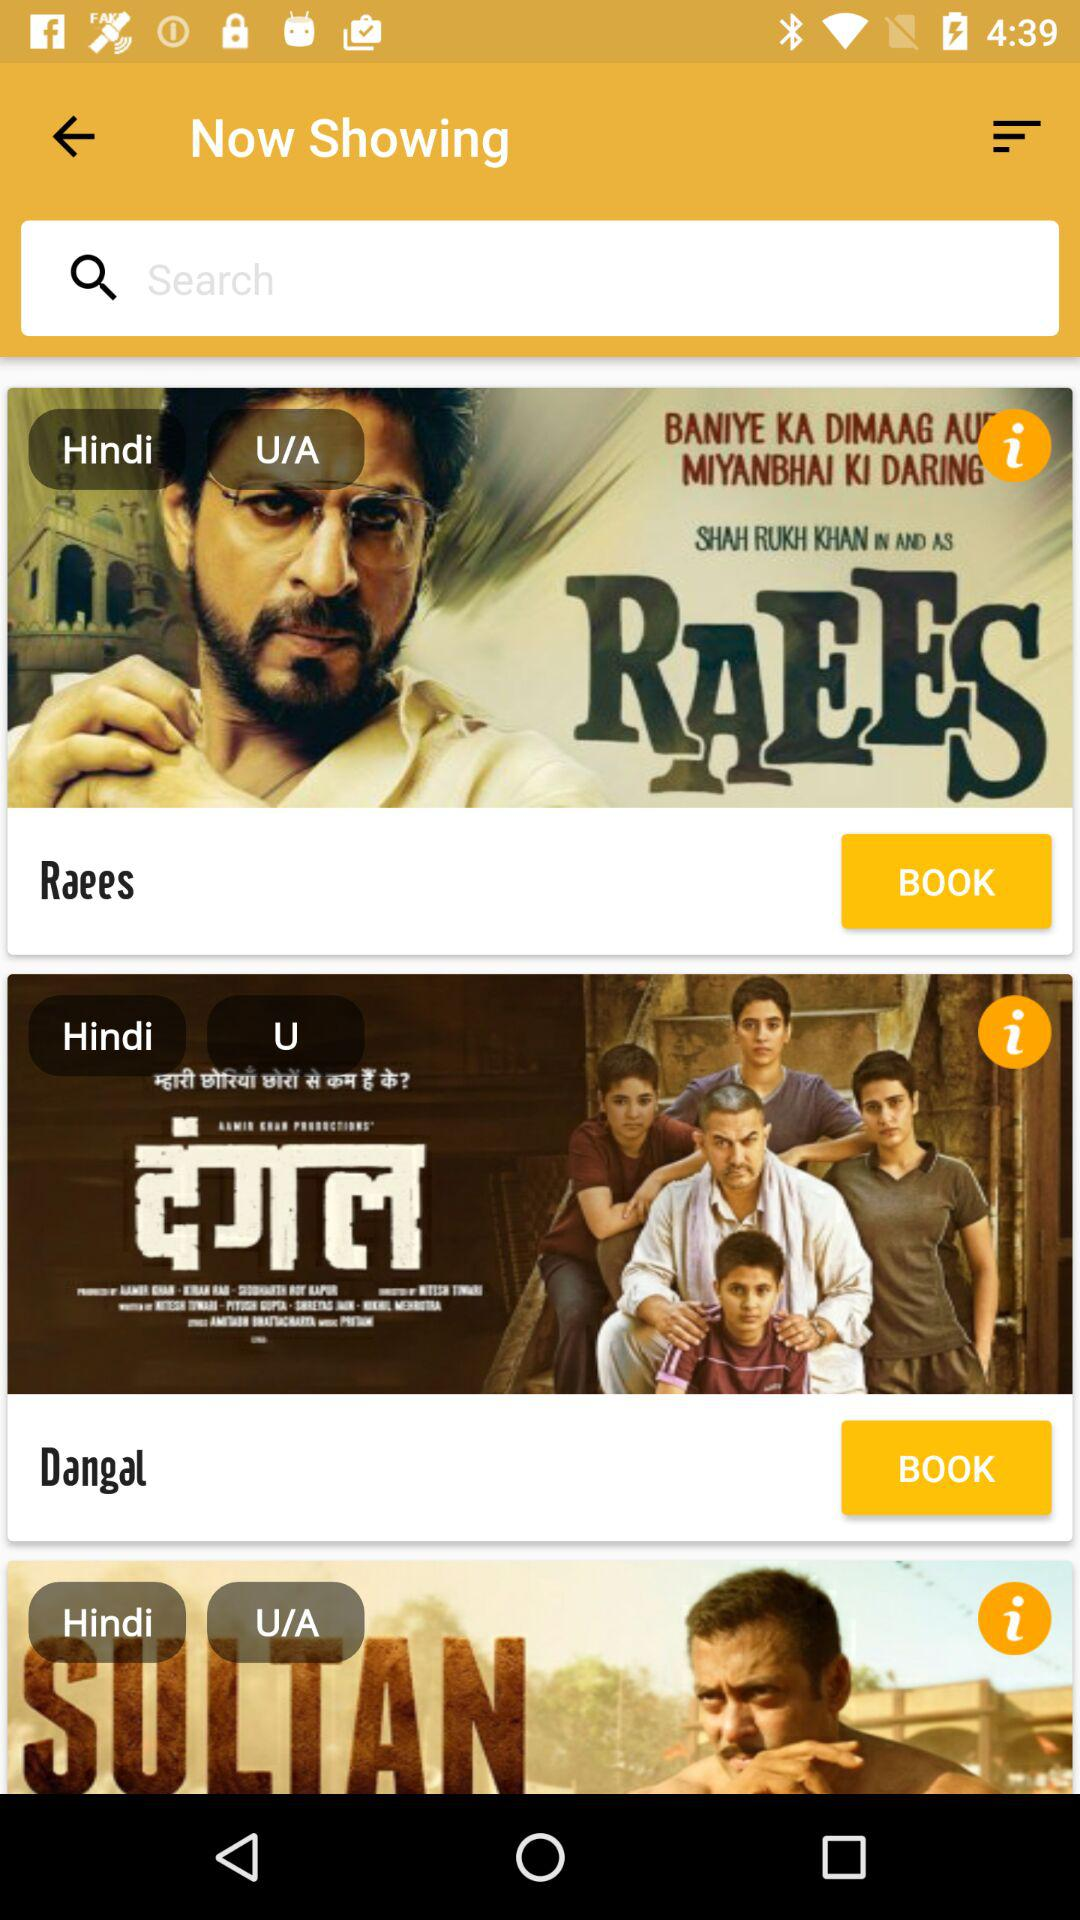What is the language of the movie "Dangal"? The language of the movie "Dangal" is Hindi. 